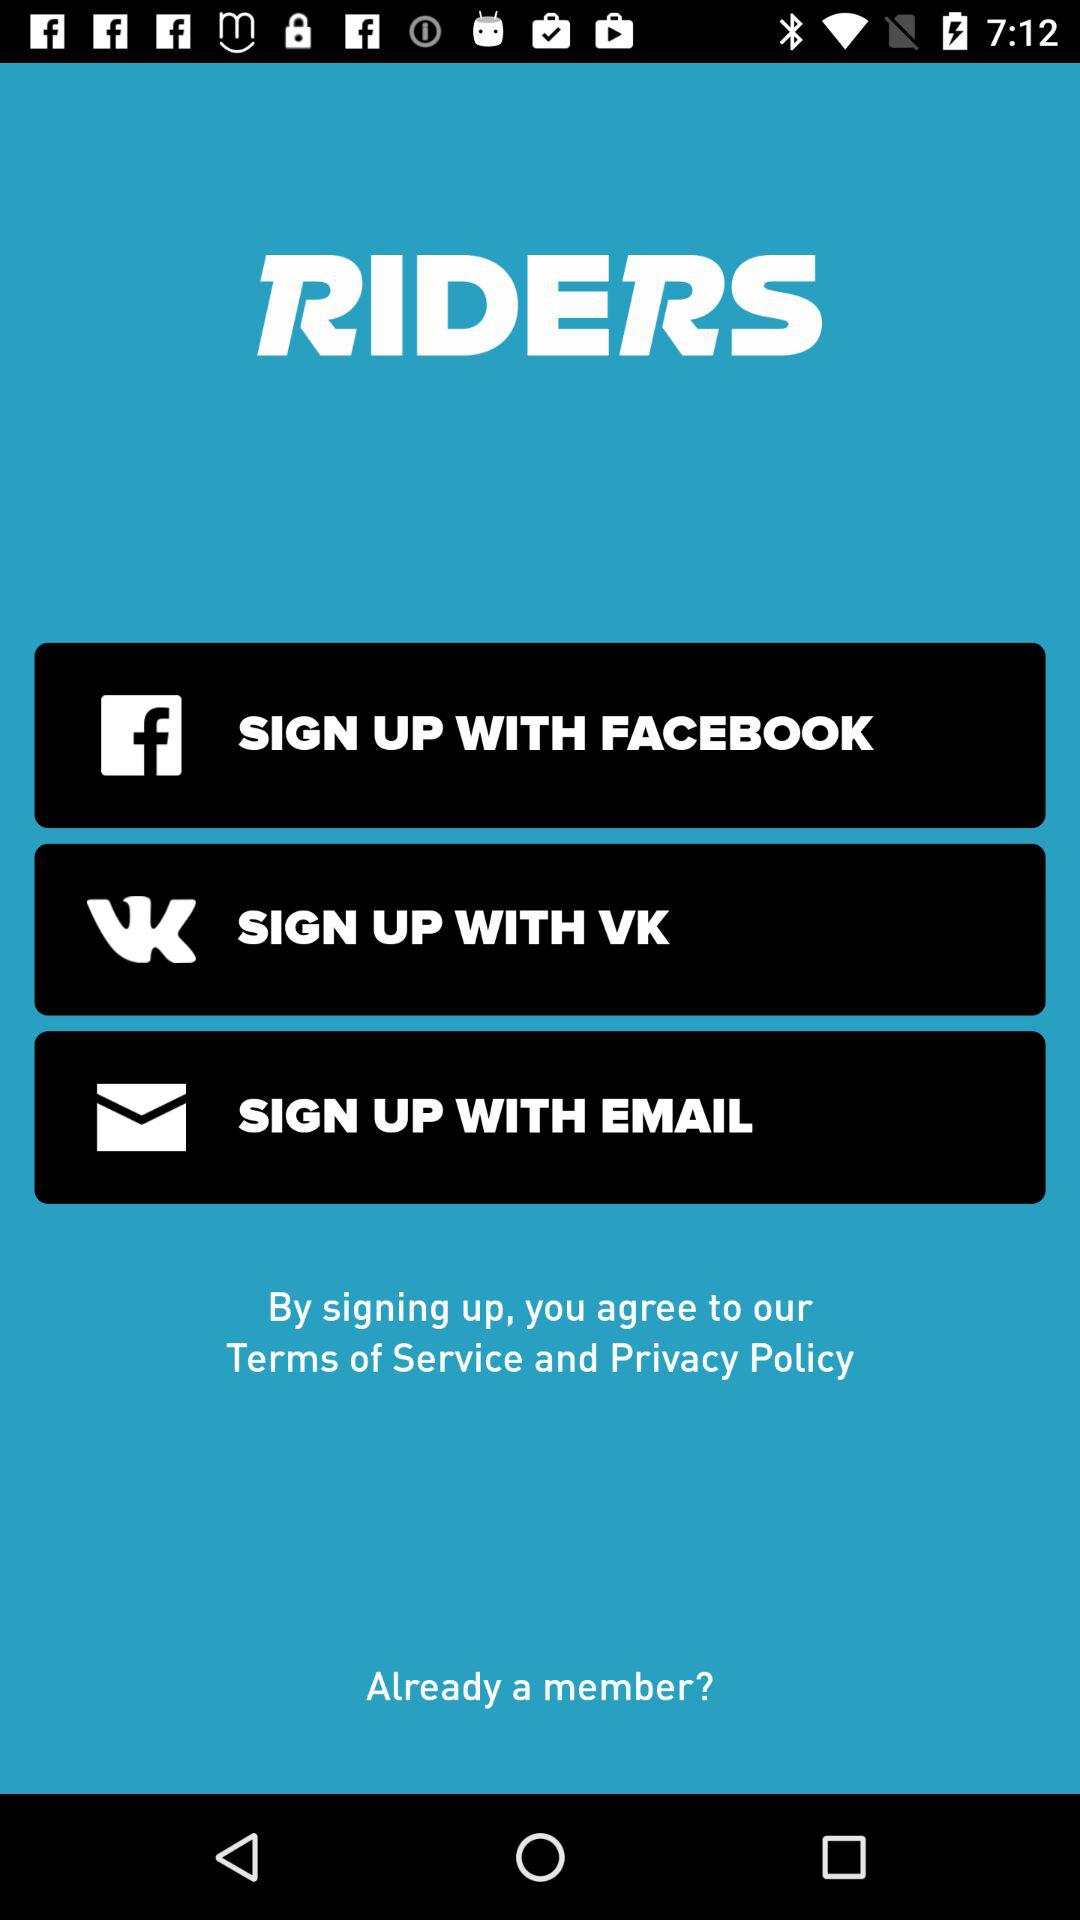What is the name of the application? The name of the application is "RIDERS". 